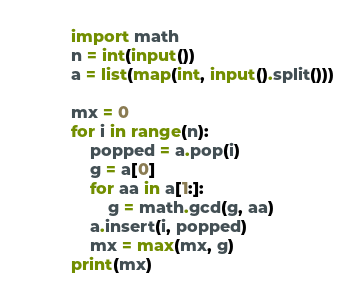Convert code to text. <code><loc_0><loc_0><loc_500><loc_500><_Python_>import math
n = int(input())
a = list(map(int, input().split()))

mx = 0
for i in range(n):
    popped = a.pop(i)
    g = a[0]
    for aa in a[1:]:
        g = math.gcd(g, aa)
    a.insert(i, popped)
    mx = max(mx, g)
print(mx)</code> 